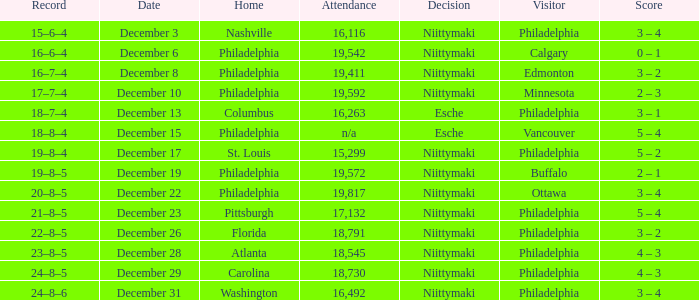What was the decision when the attendance was 19,592? Niittymaki. 